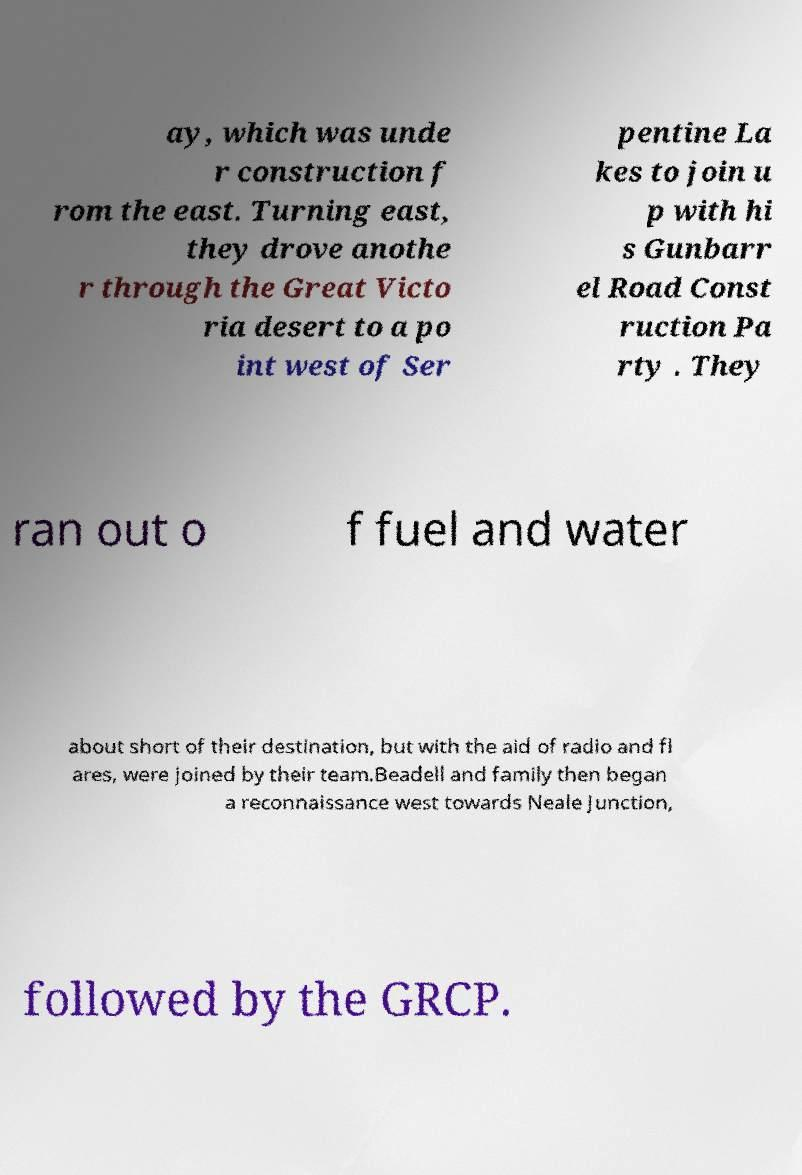I need the written content from this picture converted into text. Can you do that? ay, which was unde r construction f rom the east. Turning east, they drove anothe r through the Great Victo ria desert to a po int west of Ser pentine La kes to join u p with hi s Gunbarr el Road Const ruction Pa rty . They ran out o f fuel and water about short of their destination, but with the aid of radio and fl ares, were joined by their team.Beadell and family then began a reconnaissance west towards Neale Junction, followed by the GRCP. 